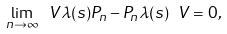Convert formula to latex. <formula><loc_0><loc_0><loc_500><loc_500>\lim _ { n \rightarrow \infty } \ V \lambda ( s ) P _ { n } - P _ { n } \lambda ( s ) \ V = 0 ,</formula> 